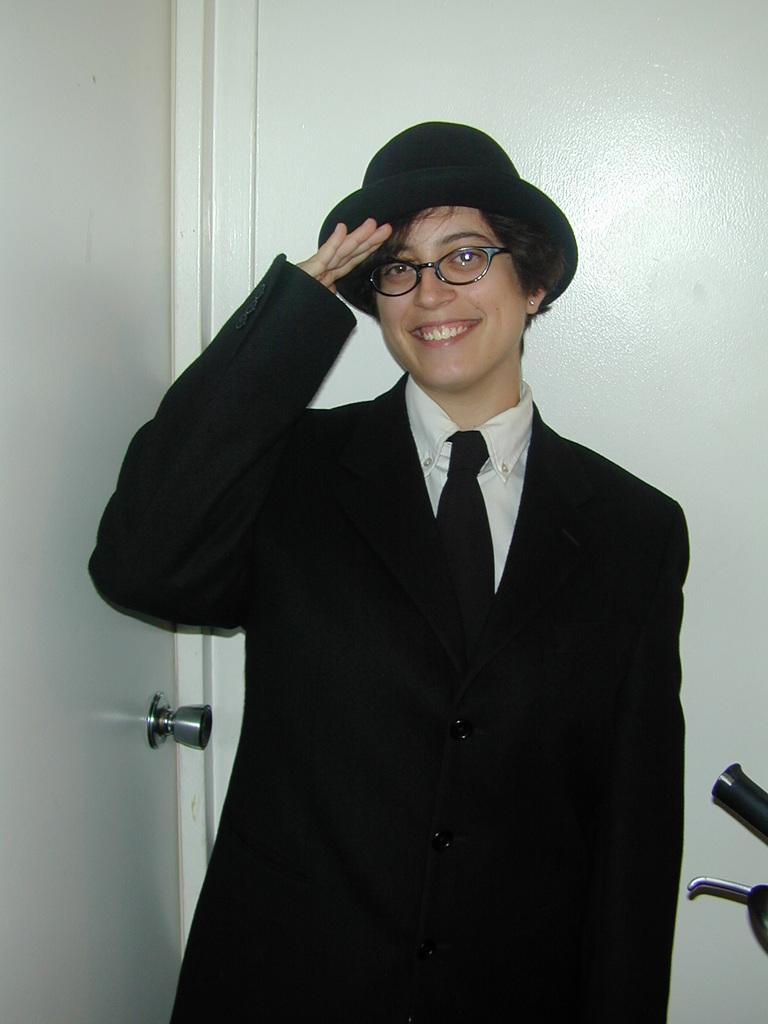Could you give a brief overview of what you see in this image? In this picture I can see a woman standing and she is wearing a cap on her head. I can see a door on the left side and a wall in the background. 